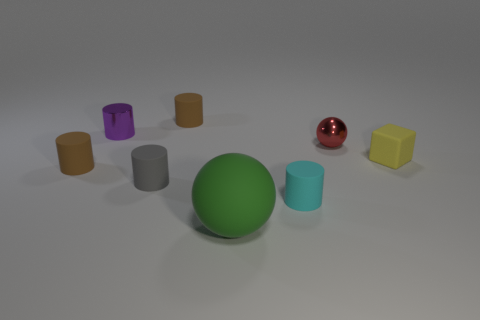How many tiny cylinders are both in front of the small yellow rubber thing and behind the tiny purple thing?
Your answer should be compact. 0. What number of other objects are there of the same material as the cube?
Give a very brief answer. 5. The sphere that is in front of the sphere behind the block is what color?
Offer a very short reply. Green. There is a tiny object on the right side of the small red shiny ball; is its color the same as the metallic cylinder?
Ensure brevity in your answer.  No. Do the red sphere and the yellow rubber cube have the same size?
Keep it short and to the point. Yes. There is a yellow matte object that is the same size as the cyan matte cylinder; what shape is it?
Give a very brief answer. Cube. There is a brown rubber thing in front of the red thing; is its size the same as the tiny cyan matte thing?
Give a very brief answer. Yes. There is a sphere that is the same size as the metallic cylinder; what is it made of?
Offer a very short reply. Metal. Is there a brown cylinder that is on the right side of the tiny brown matte object in front of the matte object behind the tiny yellow block?
Provide a short and direct response. Yes. Is there any other thing that has the same shape as the gray rubber thing?
Keep it short and to the point. Yes. 